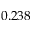<formula> <loc_0><loc_0><loc_500><loc_500>0 . 2 3 8</formula> 